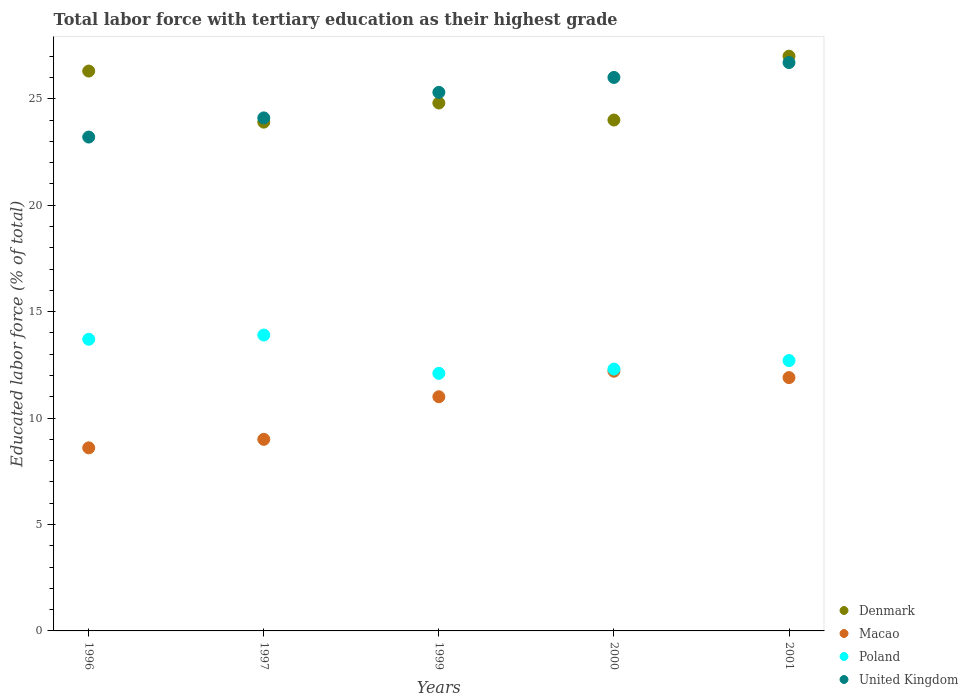What is the percentage of male labor force with tertiary education in Denmark in 1997?
Offer a terse response. 23.9. Across all years, what is the maximum percentage of male labor force with tertiary education in United Kingdom?
Offer a very short reply. 26.7. Across all years, what is the minimum percentage of male labor force with tertiary education in United Kingdom?
Offer a terse response. 23.2. In which year was the percentage of male labor force with tertiary education in United Kingdom minimum?
Your answer should be compact. 1996. What is the total percentage of male labor force with tertiary education in United Kingdom in the graph?
Provide a succinct answer. 125.3. What is the difference between the percentage of male labor force with tertiary education in United Kingdom in 2000 and that in 2001?
Your answer should be compact. -0.7. What is the difference between the percentage of male labor force with tertiary education in Denmark in 1997 and the percentage of male labor force with tertiary education in United Kingdom in 1996?
Provide a succinct answer. 0.7. What is the average percentage of male labor force with tertiary education in Poland per year?
Offer a terse response. 12.94. In the year 2000, what is the difference between the percentage of male labor force with tertiary education in Macao and percentage of male labor force with tertiary education in Denmark?
Offer a very short reply. -11.8. What is the ratio of the percentage of male labor force with tertiary education in Macao in 1999 to that in 2000?
Provide a short and direct response. 0.9. Is the percentage of male labor force with tertiary education in United Kingdom in 1996 less than that in 1999?
Your answer should be very brief. Yes. What is the difference between the highest and the second highest percentage of male labor force with tertiary education in United Kingdom?
Make the answer very short. 0.7. What is the difference between the highest and the lowest percentage of male labor force with tertiary education in United Kingdom?
Provide a short and direct response. 3.5. In how many years, is the percentage of male labor force with tertiary education in Poland greater than the average percentage of male labor force with tertiary education in Poland taken over all years?
Provide a succinct answer. 2. Is it the case that in every year, the sum of the percentage of male labor force with tertiary education in Denmark and percentage of male labor force with tertiary education in Macao  is greater than the sum of percentage of male labor force with tertiary education in Poland and percentage of male labor force with tertiary education in United Kingdom?
Provide a short and direct response. No. Does the percentage of male labor force with tertiary education in Macao monotonically increase over the years?
Keep it short and to the point. No. Is the percentage of male labor force with tertiary education in United Kingdom strictly greater than the percentage of male labor force with tertiary education in Poland over the years?
Make the answer very short. Yes. Is the percentage of male labor force with tertiary education in Macao strictly less than the percentage of male labor force with tertiary education in Denmark over the years?
Make the answer very short. Yes. Are the values on the major ticks of Y-axis written in scientific E-notation?
Offer a terse response. No. Does the graph contain any zero values?
Give a very brief answer. No. Does the graph contain grids?
Make the answer very short. No. Where does the legend appear in the graph?
Give a very brief answer. Bottom right. How many legend labels are there?
Provide a short and direct response. 4. What is the title of the graph?
Your answer should be very brief. Total labor force with tertiary education as their highest grade. Does "Ethiopia" appear as one of the legend labels in the graph?
Keep it short and to the point. No. What is the label or title of the X-axis?
Offer a very short reply. Years. What is the label or title of the Y-axis?
Give a very brief answer. Educated labor force (% of total). What is the Educated labor force (% of total) in Denmark in 1996?
Your answer should be compact. 26.3. What is the Educated labor force (% of total) in Macao in 1996?
Your response must be concise. 8.6. What is the Educated labor force (% of total) of Poland in 1996?
Offer a terse response. 13.7. What is the Educated labor force (% of total) of United Kingdom in 1996?
Make the answer very short. 23.2. What is the Educated labor force (% of total) of Denmark in 1997?
Provide a short and direct response. 23.9. What is the Educated labor force (% of total) in Poland in 1997?
Offer a terse response. 13.9. What is the Educated labor force (% of total) in United Kingdom in 1997?
Give a very brief answer. 24.1. What is the Educated labor force (% of total) in Denmark in 1999?
Give a very brief answer. 24.8. What is the Educated labor force (% of total) in Poland in 1999?
Your answer should be compact. 12.1. What is the Educated labor force (% of total) of United Kingdom in 1999?
Give a very brief answer. 25.3. What is the Educated labor force (% of total) in Denmark in 2000?
Offer a very short reply. 24. What is the Educated labor force (% of total) of Macao in 2000?
Keep it short and to the point. 12.2. What is the Educated labor force (% of total) of Poland in 2000?
Offer a terse response. 12.3. What is the Educated labor force (% of total) of United Kingdom in 2000?
Your response must be concise. 26. What is the Educated labor force (% of total) in Macao in 2001?
Your response must be concise. 11.9. What is the Educated labor force (% of total) in Poland in 2001?
Your answer should be compact. 12.7. What is the Educated labor force (% of total) in United Kingdom in 2001?
Ensure brevity in your answer.  26.7. Across all years, what is the maximum Educated labor force (% of total) of Macao?
Ensure brevity in your answer.  12.2. Across all years, what is the maximum Educated labor force (% of total) of Poland?
Your answer should be compact. 13.9. Across all years, what is the maximum Educated labor force (% of total) of United Kingdom?
Your answer should be compact. 26.7. Across all years, what is the minimum Educated labor force (% of total) in Denmark?
Keep it short and to the point. 23.9. Across all years, what is the minimum Educated labor force (% of total) in Macao?
Give a very brief answer. 8.6. Across all years, what is the minimum Educated labor force (% of total) of Poland?
Provide a succinct answer. 12.1. Across all years, what is the minimum Educated labor force (% of total) in United Kingdom?
Make the answer very short. 23.2. What is the total Educated labor force (% of total) in Denmark in the graph?
Ensure brevity in your answer.  126. What is the total Educated labor force (% of total) of Macao in the graph?
Your answer should be very brief. 52.7. What is the total Educated labor force (% of total) in Poland in the graph?
Ensure brevity in your answer.  64.7. What is the total Educated labor force (% of total) in United Kingdom in the graph?
Make the answer very short. 125.3. What is the difference between the Educated labor force (% of total) in Macao in 1996 and that in 1997?
Offer a terse response. -0.4. What is the difference between the Educated labor force (% of total) in Denmark in 1996 and that in 1999?
Make the answer very short. 1.5. What is the difference between the Educated labor force (% of total) of Macao in 1996 and that in 1999?
Offer a terse response. -2.4. What is the difference between the Educated labor force (% of total) of Poland in 1996 and that in 1999?
Provide a short and direct response. 1.6. What is the difference between the Educated labor force (% of total) in Poland in 1996 and that in 2000?
Make the answer very short. 1.4. What is the difference between the Educated labor force (% of total) of Macao in 1996 and that in 2001?
Make the answer very short. -3.3. What is the difference between the Educated labor force (% of total) in Poland in 1996 and that in 2001?
Your answer should be very brief. 1. What is the difference between the Educated labor force (% of total) of United Kingdom in 1996 and that in 2001?
Provide a succinct answer. -3.5. What is the difference between the Educated labor force (% of total) in United Kingdom in 1997 and that in 1999?
Make the answer very short. -1.2. What is the difference between the Educated labor force (% of total) of Macao in 1997 and that in 2000?
Provide a succinct answer. -3.2. What is the difference between the Educated labor force (% of total) of Macao in 1999 and that in 2000?
Make the answer very short. -1.2. What is the difference between the Educated labor force (% of total) in Denmark in 2000 and that in 2001?
Your answer should be compact. -3. What is the difference between the Educated labor force (% of total) in Macao in 2000 and that in 2001?
Your answer should be compact. 0.3. What is the difference between the Educated labor force (% of total) of Poland in 2000 and that in 2001?
Make the answer very short. -0.4. What is the difference between the Educated labor force (% of total) of United Kingdom in 2000 and that in 2001?
Your answer should be very brief. -0.7. What is the difference between the Educated labor force (% of total) in Denmark in 1996 and the Educated labor force (% of total) in Macao in 1997?
Keep it short and to the point. 17.3. What is the difference between the Educated labor force (% of total) of Macao in 1996 and the Educated labor force (% of total) of Poland in 1997?
Offer a terse response. -5.3. What is the difference between the Educated labor force (% of total) in Macao in 1996 and the Educated labor force (% of total) in United Kingdom in 1997?
Ensure brevity in your answer.  -15.5. What is the difference between the Educated labor force (% of total) in Denmark in 1996 and the Educated labor force (% of total) in Macao in 1999?
Offer a very short reply. 15.3. What is the difference between the Educated labor force (% of total) in Denmark in 1996 and the Educated labor force (% of total) in Poland in 1999?
Keep it short and to the point. 14.2. What is the difference between the Educated labor force (% of total) of Denmark in 1996 and the Educated labor force (% of total) of United Kingdom in 1999?
Make the answer very short. 1. What is the difference between the Educated labor force (% of total) of Macao in 1996 and the Educated labor force (% of total) of Poland in 1999?
Keep it short and to the point. -3.5. What is the difference between the Educated labor force (% of total) of Macao in 1996 and the Educated labor force (% of total) of United Kingdom in 1999?
Your answer should be compact. -16.7. What is the difference between the Educated labor force (% of total) in Denmark in 1996 and the Educated labor force (% of total) in Macao in 2000?
Your answer should be very brief. 14.1. What is the difference between the Educated labor force (% of total) of Denmark in 1996 and the Educated labor force (% of total) of Poland in 2000?
Your answer should be very brief. 14. What is the difference between the Educated labor force (% of total) in Macao in 1996 and the Educated labor force (% of total) in United Kingdom in 2000?
Make the answer very short. -17.4. What is the difference between the Educated labor force (% of total) in Denmark in 1996 and the Educated labor force (% of total) in Poland in 2001?
Make the answer very short. 13.6. What is the difference between the Educated labor force (% of total) of Macao in 1996 and the Educated labor force (% of total) of United Kingdom in 2001?
Give a very brief answer. -18.1. What is the difference between the Educated labor force (% of total) in Poland in 1996 and the Educated labor force (% of total) in United Kingdom in 2001?
Keep it short and to the point. -13. What is the difference between the Educated labor force (% of total) of Denmark in 1997 and the Educated labor force (% of total) of Poland in 1999?
Keep it short and to the point. 11.8. What is the difference between the Educated labor force (% of total) of Denmark in 1997 and the Educated labor force (% of total) of United Kingdom in 1999?
Your answer should be very brief. -1.4. What is the difference between the Educated labor force (% of total) of Macao in 1997 and the Educated labor force (% of total) of Poland in 1999?
Ensure brevity in your answer.  -3.1. What is the difference between the Educated labor force (% of total) of Macao in 1997 and the Educated labor force (% of total) of United Kingdom in 1999?
Offer a terse response. -16.3. What is the difference between the Educated labor force (% of total) in Denmark in 1997 and the Educated labor force (% of total) in Macao in 2000?
Your answer should be compact. 11.7. What is the difference between the Educated labor force (% of total) of Denmark in 1997 and the Educated labor force (% of total) of Poland in 2000?
Make the answer very short. 11.6. What is the difference between the Educated labor force (% of total) of Denmark in 1997 and the Educated labor force (% of total) of United Kingdom in 2001?
Your answer should be very brief. -2.8. What is the difference between the Educated labor force (% of total) in Macao in 1997 and the Educated labor force (% of total) in United Kingdom in 2001?
Offer a terse response. -17.7. What is the difference between the Educated labor force (% of total) in Poland in 1997 and the Educated labor force (% of total) in United Kingdom in 2001?
Give a very brief answer. -12.8. What is the difference between the Educated labor force (% of total) of Denmark in 1999 and the Educated labor force (% of total) of Poland in 2000?
Make the answer very short. 12.5. What is the difference between the Educated labor force (% of total) in Macao in 1999 and the Educated labor force (% of total) in Poland in 2000?
Provide a succinct answer. -1.3. What is the difference between the Educated labor force (% of total) of Poland in 1999 and the Educated labor force (% of total) of United Kingdom in 2000?
Provide a short and direct response. -13.9. What is the difference between the Educated labor force (% of total) in Denmark in 1999 and the Educated labor force (% of total) in Macao in 2001?
Your response must be concise. 12.9. What is the difference between the Educated labor force (% of total) of Macao in 1999 and the Educated labor force (% of total) of United Kingdom in 2001?
Offer a terse response. -15.7. What is the difference between the Educated labor force (% of total) in Poland in 1999 and the Educated labor force (% of total) in United Kingdom in 2001?
Provide a short and direct response. -14.6. What is the difference between the Educated labor force (% of total) of Denmark in 2000 and the Educated labor force (% of total) of Macao in 2001?
Offer a very short reply. 12.1. What is the difference between the Educated labor force (% of total) in Denmark in 2000 and the Educated labor force (% of total) in United Kingdom in 2001?
Your answer should be compact. -2.7. What is the difference between the Educated labor force (% of total) in Macao in 2000 and the Educated labor force (% of total) in Poland in 2001?
Ensure brevity in your answer.  -0.5. What is the difference between the Educated labor force (% of total) in Macao in 2000 and the Educated labor force (% of total) in United Kingdom in 2001?
Your answer should be very brief. -14.5. What is the difference between the Educated labor force (% of total) of Poland in 2000 and the Educated labor force (% of total) of United Kingdom in 2001?
Keep it short and to the point. -14.4. What is the average Educated labor force (% of total) in Denmark per year?
Make the answer very short. 25.2. What is the average Educated labor force (% of total) of Macao per year?
Offer a terse response. 10.54. What is the average Educated labor force (% of total) in Poland per year?
Your answer should be very brief. 12.94. What is the average Educated labor force (% of total) in United Kingdom per year?
Your answer should be very brief. 25.06. In the year 1996, what is the difference between the Educated labor force (% of total) of Denmark and Educated labor force (% of total) of Macao?
Provide a short and direct response. 17.7. In the year 1996, what is the difference between the Educated labor force (% of total) in Denmark and Educated labor force (% of total) in Poland?
Your answer should be very brief. 12.6. In the year 1996, what is the difference between the Educated labor force (% of total) of Denmark and Educated labor force (% of total) of United Kingdom?
Offer a very short reply. 3.1. In the year 1996, what is the difference between the Educated labor force (% of total) of Macao and Educated labor force (% of total) of Poland?
Offer a terse response. -5.1. In the year 1996, what is the difference between the Educated labor force (% of total) in Macao and Educated labor force (% of total) in United Kingdom?
Provide a succinct answer. -14.6. In the year 1997, what is the difference between the Educated labor force (% of total) of Denmark and Educated labor force (% of total) of Macao?
Provide a succinct answer. 14.9. In the year 1997, what is the difference between the Educated labor force (% of total) in Denmark and Educated labor force (% of total) in Poland?
Ensure brevity in your answer.  10. In the year 1997, what is the difference between the Educated labor force (% of total) in Macao and Educated labor force (% of total) in Poland?
Make the answer very short. -4.9. In the year 1997, what is the difference between the Educated labor force (% of total) of Macao and Educated labor force (% of total) of United Kingdom?
Keep it short and to the point. -15.1. In the year 1997, what is the difference between the Educated labor force (% of total) in Poland and Educated labor force (% of total) in United Kingdom?
Make the answer very short. -10.2. In the year 1999, what is the difference between the Educated labor force (% of total) of Denmark and Educated labor force (% of total) of Macao?
Your response must be concise. 13.8. In the year 1999, what is the difference between the Educated labor force (% of total) in Denmark and Educated labor force (% of total) in Poland?
Offer a very short reply. 12.7. In the year 1999, what is the difference between the Educated labor force (% of total) in Denmark and Educated labor force (% of total) in United Kingdom?
Ensure brevity in your answer.  -0.5. In the year 1999, what is the difference between the Educated labor force (% of total) in Macao and Educated labor force (% of total) in United Kingdom?
Give a very brief answer. -14.3. In the year 2000, what is the difference between the Educated labor force (% of total) in Denmark and Educated labor force (% of total) in Poland?
Keep it short and to the point. 11.7. In the year 2000, what is the difference between the Educated labor force (% of total) in Macao and Educated labor force (% of total) in Poland?
Ensure brevity in your answer.  -0.1. In the year 2000, what is the difference between the Educated labor force (% of total) in Macao and Educated labor force (% of total) in United Kingdom?
Ensure brevity in your answer.  -13.8. In the year 2000, what is the difference between the Educated labor force (% of total) in Poland and Educated labor force (% of total) in United Kingdom?
Keep it short and to the point. -13.7. In the year 2001, what is the difference between the Educated labor force (% of total) of Denmark and Educated labor force (% of total) of Macao?
Your answer should be compact. 15.1. In the year 2001, what is the difference between the Educated labor force (% of total) in Denmark and Educated labor force (% of total) in Poland?
Provide a succinct answer. 14.3. In the year 2001, what is the difference between the Educated labor force (% of total) in Macao and Educated labor force (% of total) in United Kingdom?
Give a very brief answer. -14.8. In the year 2001, what is the difference between the Educated labor force (% of total) of Poland and Educated labor force (% of total) of United Kingdom?
Keep it short and to the point. -14. What is the ratio of the Educated labor force (% of total) in Denmark in 1996 to that in 1997?
Your answer should be compact. 1.1. What is the ratio of the Educated labor force (% of total) in Macao in 1996 to that in 1997?
Give a very brief answer. 0.96. What is the ratio of the Educated labor force (% of total) of Poland in 1996 to that in 1997?
Keep it short and to the point. 0.99. What is the ratio of the Educated labor force (% of total) of United Kingdom in 1996 to that in 1997?
Your answer should be very brief. 0.96. What is the ratio of the Educated labor force (% of total) of Denmark in 1996 to that in 1999?
Provide a short and direct response. 1.06. What is the ratio of the Educated labor force (% of total) of Macao in 1996 to that in 1999?
Make the answer very short. 0.78. What is the ratio of the Educated labor force (% of total) of Poland in 1996 to that in 1999?
Give a very brief answer. 1.13. What is the ratio of the Educated labor force (% of total) of United Kingdom in 1996 to that in 1999?
Your answer should be compact. 0.92. What is the ratio of the Educated labor force (% of total) of Denmark in 1996 to that in 2000?
Ensure brevity in your answer.  1.1. What is the ratio of the Educated labor force (% of total) of Macao in 1996 to that in 2000?
Your answer should be very brief. 0.7. What is the ratio of the Educated labor force (% of total) of Poland in 1996 to that in 2000?
Offer a terse response. 1.11. What is the ratio of the Educated labor force (% of total) in United Kingdom in 1996 to that in 2000?
Give a very brief answer. 0.89. What is the ratio of the Educated labor force (% of total) of Denmark in 1996 to that in 2001?
Your answer should be very brief. 0.97. What is the ratio of the Educated labor force (% of total) in Macao in 1996 to that in 2001?
Provide a succinct answer. 0.72. What is the ratio of the Educated labor force (% of total) of Poland in 1996 to that in 2001?
Give a very brief answer. 1.08. What is the ratio of the Educated labor force (% of total) in United Kingdom in 1996 to that in 2001?
Offer a terse response. 0.87. What is the ratio of the Educated labor force (% of total) in Denmark in 1997 to that in 1999?
Make the answer very short. 0.96. What is the ratio of the Educated labor force (% of total) of Macao in 1997 to that in 1999?
Offer a terse response. 0.82. What is the ratio of the Educated labor force (% of total) in Poland in 1997 to that in 1999?
Keep it short and to the point. 1.15. What is the ratio of the Educated labor force (% of total) of United Kingdom in 1997 to that in 1999?
Offer a terse response. 0.95. What is the ratio of the Educated labor force (% of total) in Denmark in 1997 to that in 2000?
Ensure brevity in your answer.  1. What is the ratio of the Educated labor force (% of total) of Macao in 1997 to that in 2000?
Offer a terse response. 0.74. What is the ratio of the Educated labor force (% of total) of Poland in 1997 to that in 2000?
Keep it short and to the point. 1.13. What is the ratio of the Educated labor force (% of total) in United Kingdom in 1997 to that in 2000?
Your answer should be compact. 0.93. What is the ratio of the Educated labor force (% of total) in Denmark in 1997 to that in 2001?
Your answer should be very brief. 0.89. What is the ratio of the Educated labor force (% of total) in Macao in 1997 to that in 2001?
Provide a short and direct response. 0.76. What is the ratio of the Educated labor force (% of total) of Poland in 1997 to that in 2001?
Your answer should be very brief. 1.09. What is the ratio of the Educated labor force (% of total) of United Kingdom in 1997 to that in 2001?
Ensure brevity in your answer.  0.9. What is the ratio of the Educated labor force (% of total) of Denmark in 1999 to that in 2000?
Ensure brevity in your answer.  1.03. What is the ratio of the Educated labor force (% of total) of Macao in 1999 to that in 2000?
Keep it short and to the point. 0.9. What is the ratio of the Educated labor force (% of total) of Poland in 1999 to that in 2000?
Your answer should be very brief. 0.98. What is the ratio of the Educated labor force (% of total) of United Kingdom in 1999 to that in 2000?
Offer a very short reply. 0.97. What is the ratio of the Educated labor force (% of total) in Denmark in 1999 to that in 2001?
Make the answer very short. 0.92. What is the ratio of the Educated labor force (% of total) of Macao in 1999 to that in 2001?
Keep it short and to the point. 0.92. What is the ratio of the Educated labor force (% of total) in Poland in 1999 to that in 2001?
Ensure brevity in your answer.  0.95. What is the ratio of the Educated labor force (% of total) in United Kingdom in 1999 to that in 2001?
Offer a very short reply. 0.95. What is the ratio of the Educated labor force (% of total) in Denmark in 2000 to that in 2001?
Provide a succinct answer. 0.89. What is the ratio of the Educated labor force (% of total) in Macao in 2000 to that in 2001?
Provide a short and direct response. 1.03. What is the ratio of the Educated labor force (% of total) in Poland in 2000 to that in 2001?
Provide a succinct answer. 0.97. What is the ratio of the Educated labor force (% of total) in United Kingdom in 2000 to that in 2001?
Make the answer very short. 0.97. What is the difference between the highest and the second highest Educated labor force (% of total) in Denmark?
Provide a succinct answer. 0.7. What is the difference between the highest and the second highest Educated labor force (% of total) in Poland?
Your answer should be compact. 0.2. What is the difference between the highest and the second highest Educated labor force (% of total) in United Kingdom?
Offer a very short reply. 0.7. What is the difference between the highest and the lowest Educated labor force (% of total) in Denmark?
Make the answer very short. 3.1. 